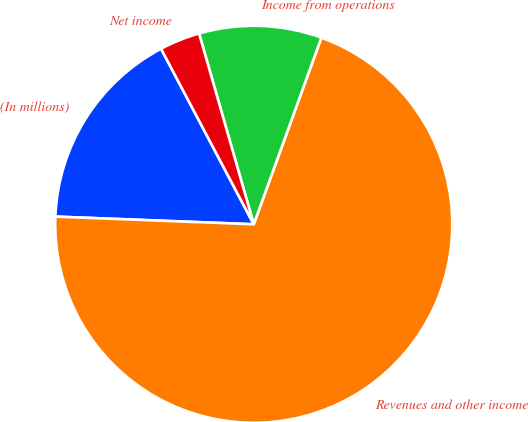Convert chart. <chart><loc_0><loc_0><loc_500><loc_500><pie_chart><fcel>(In millions)<fcel>Revenues and other income<fcel>Income from operations<fcel>Net income<nl><fcel>16.65%<fcel>70.08%<fcel>9.97%<fcel>3.29%<nl></chart> 